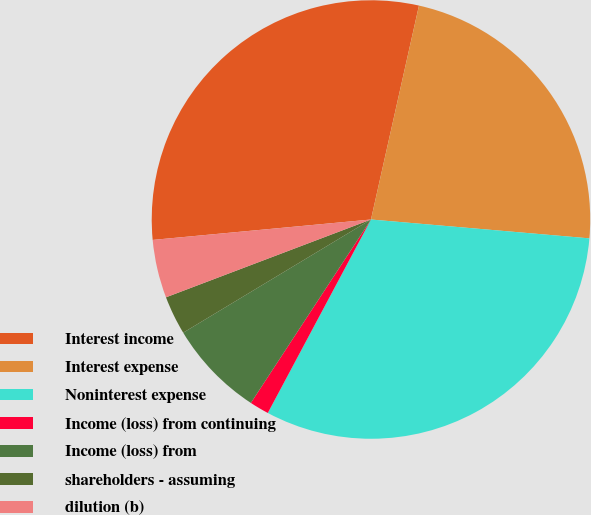<chart> <loc_0><loc_0><loc_500><loc_500><pie_chart><fcel>Interest income<fcel>Interest expense<fcel>Noninterest expense<fcel>Income (loss) from continuing<fcel>Income (loss) from<fcel>shareholders - assuming<fcel>dilution (b)<nl><fcel>30.0%<fcel>22.86%<fcel>31.43%<fcel>1.43%<fcel>7.14%<fcel>2.86%<fcel>4.29%<nl></chart> 